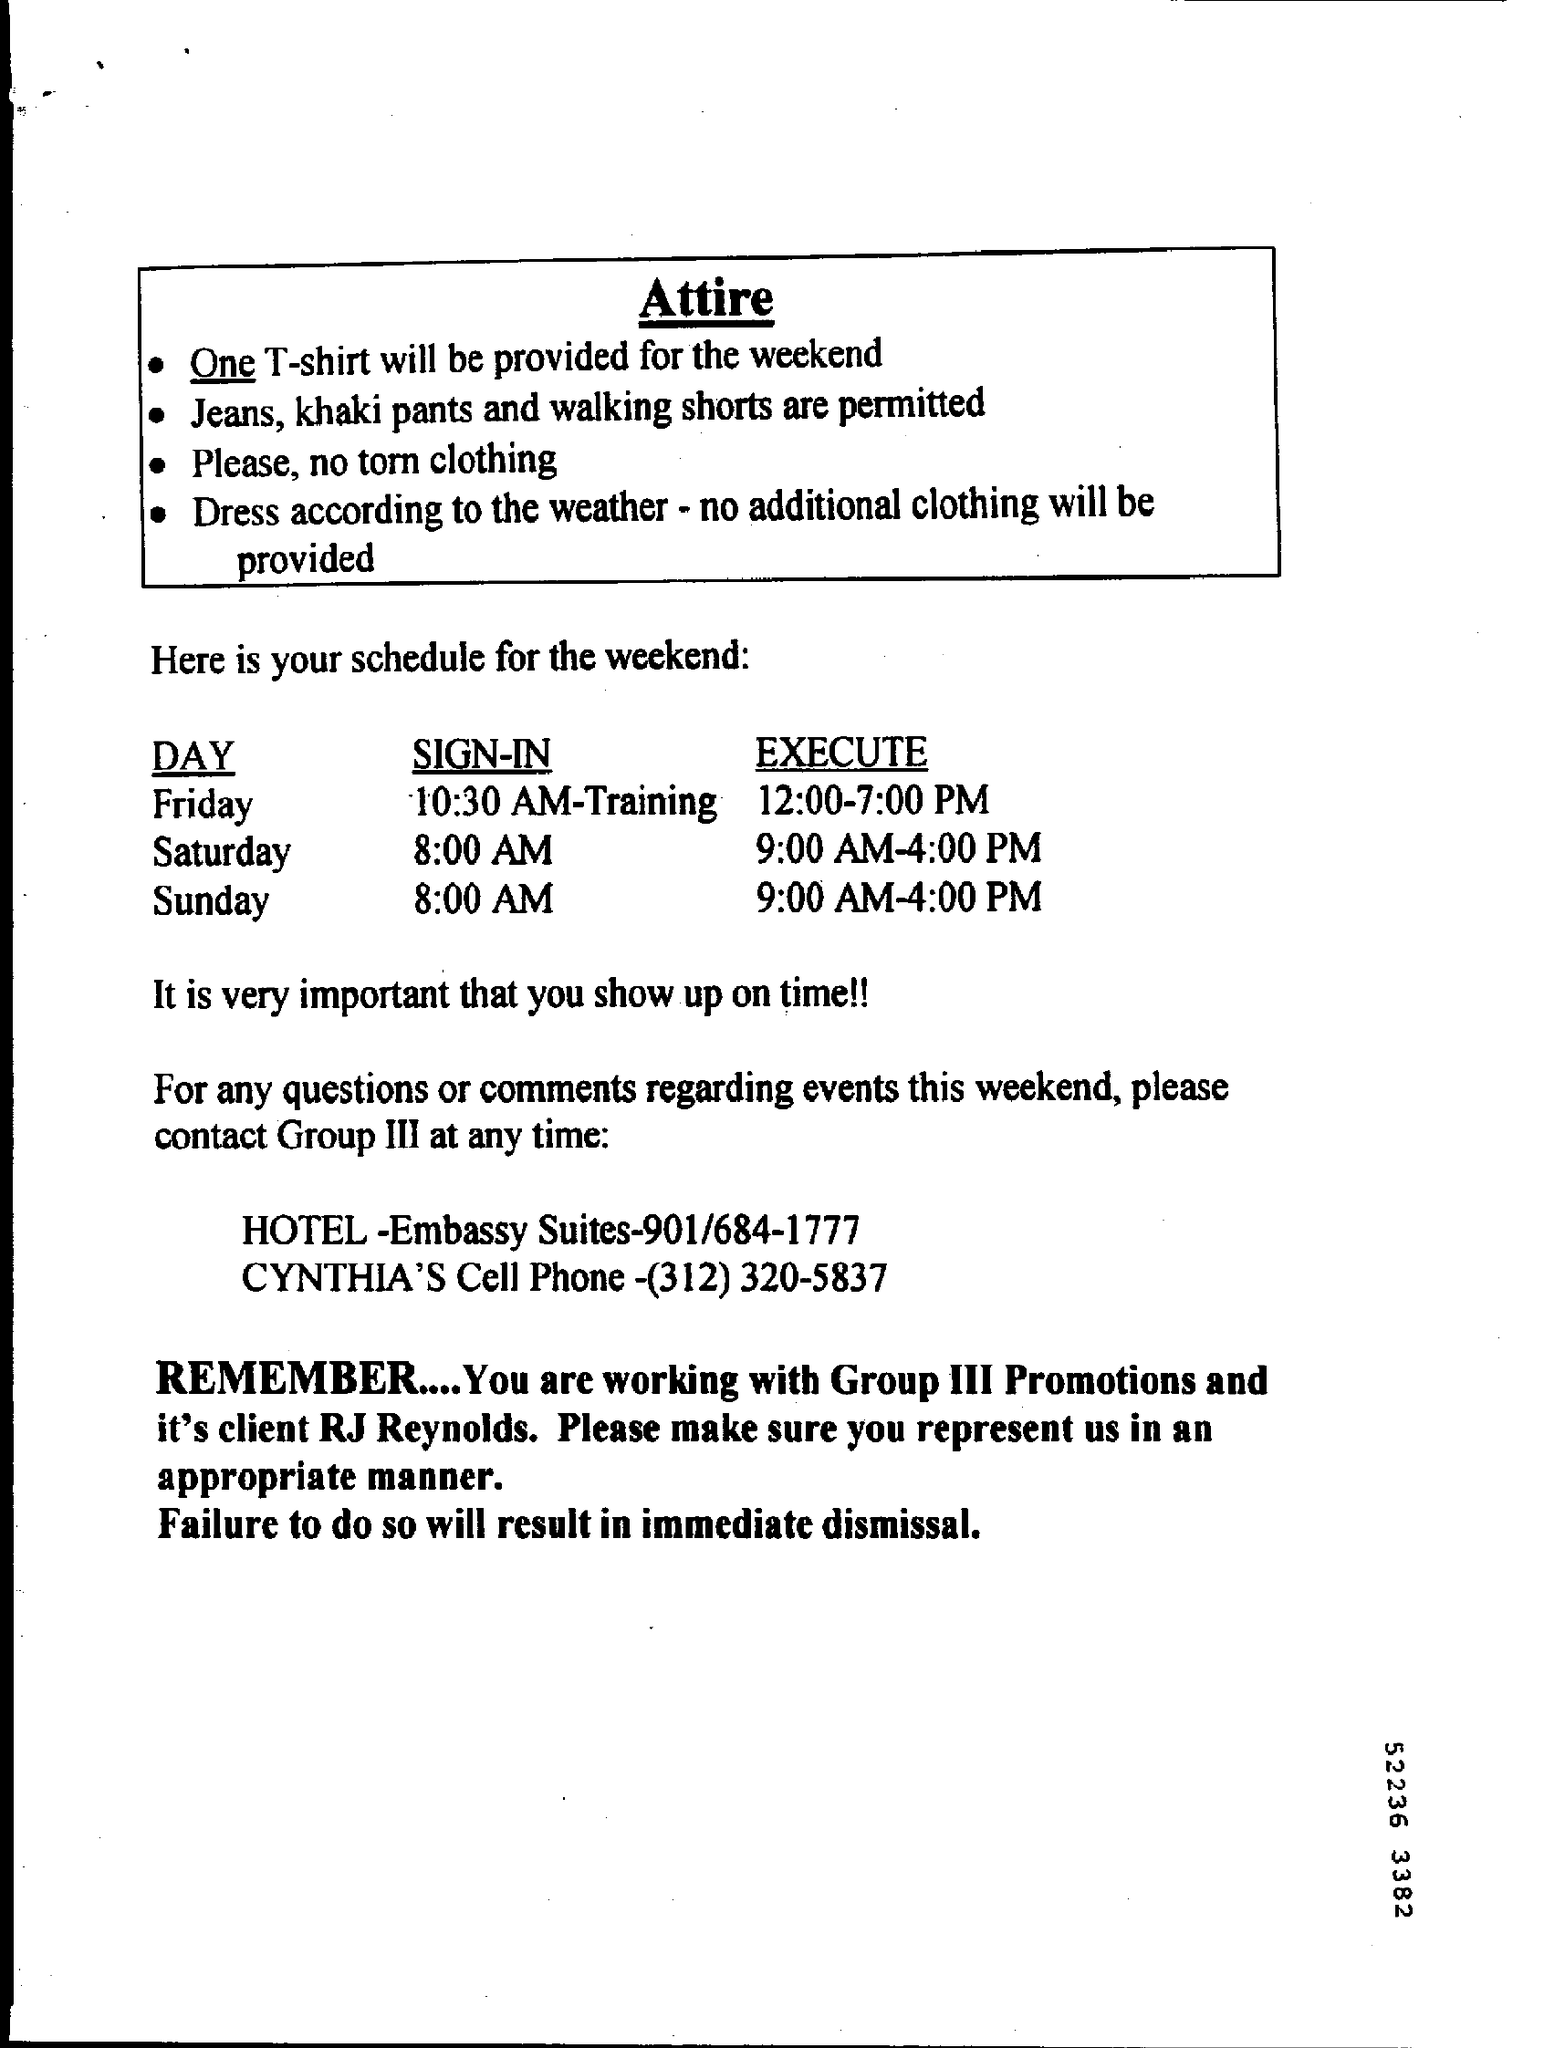How many t-shirt will be provided for the weekend?
Keep it short and to the point. One. Friday, at what time is the training?
Provide a succinct answer. 10:30 AM. What is the cell phone number of cynthia?
Offer a terse response. (312) 320-5837. Who is the client of group III promotions?
Give a very brief answer. RJ REYNOLDS. 